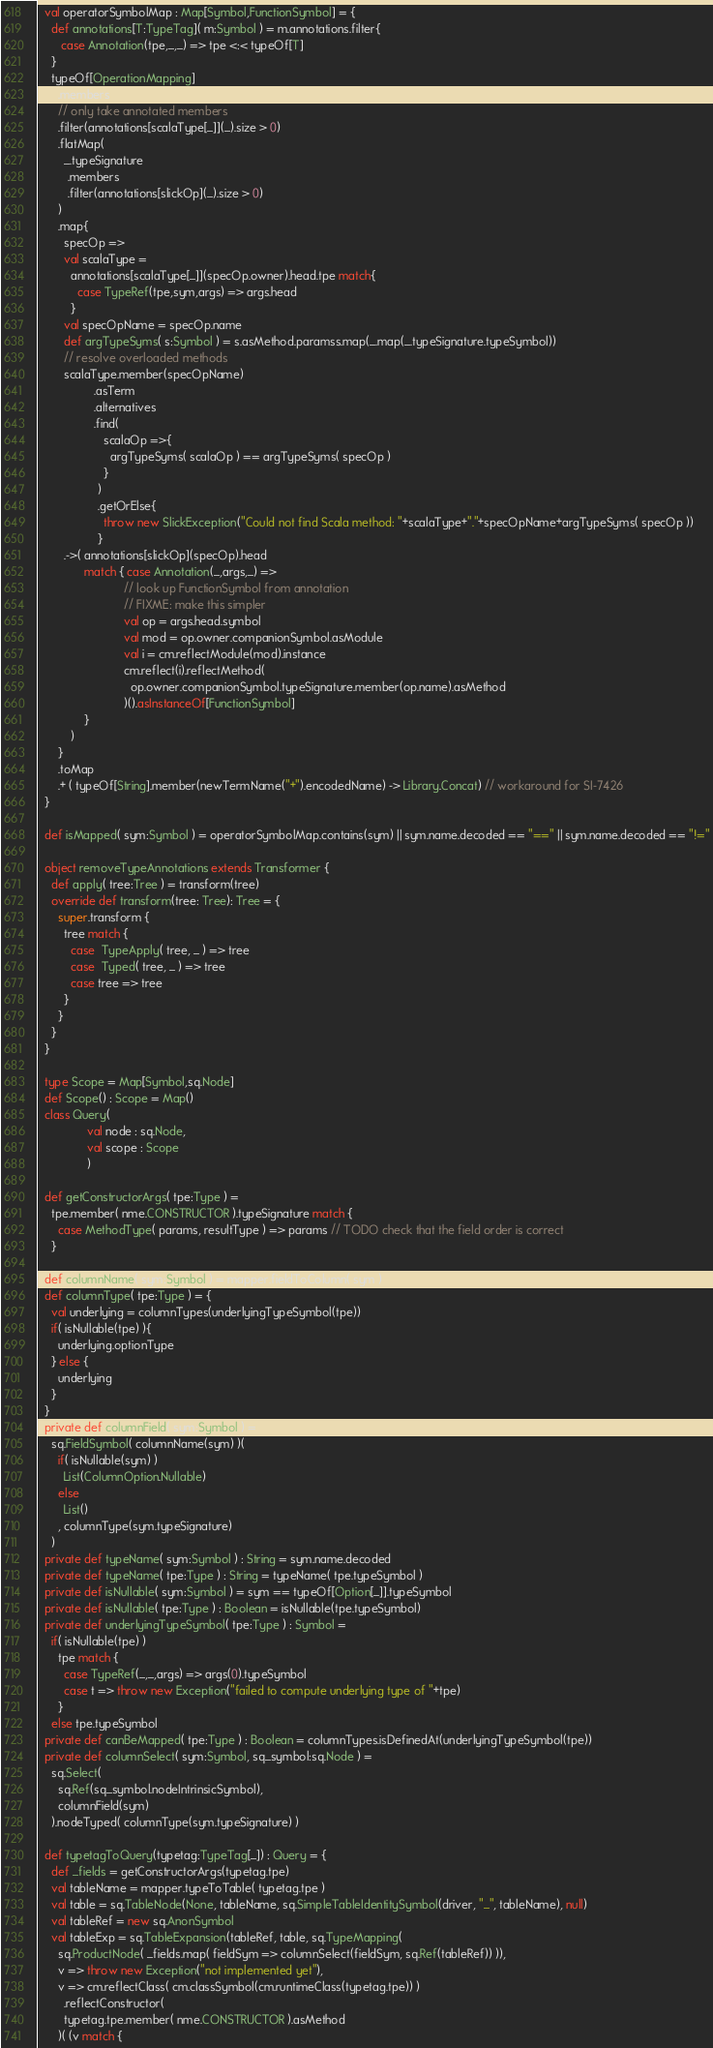Convert code to text. <code><loc_0><loc_0><loc_500><loc_500><_Scala_>  val operatorSymbolMap : Map[Symbol,FunctionSymbol] = {
    def annotations[T:TypeTag]( m:Symbol ) = m.annotations.filter{
       case Annotation(tpe,_,_) => tpe <:< typeOf[T]
    }
    typeOf[OperationMapping]
      .members
      // only take annotated members
      .filter(annotations[scalaType[_]](_).size > 0)
      .flatMap(
        _.typeSignature
         .members
         .filter(annotations[slickOp](_).size > 0)
      )
      .map{
        specOp =>
        val scalaType = 
          annotations[scalaType[_]](specOp.owner).head.tpe match{
            case TypeRef(tpe,sym,args) => args.head
          }
        val specOpName = specOp.name
        def argTypeSyms( s:Symbol ) = s.asMethod.paramss.map(_.map(_.typeSignature.typeSymbol))
        // resolve overloaded methods
        scalaType.member(specOpName) 
                 .asTerm
                 .alternatives
                 .find(
                    scalaOp =>{
                      argTypeSyms( scalaOp ) == argTypeSyms( specOp )
                    }
                  )
                  .getOrElse{
                    throw new SlickException("Could not find Scala method: "+scalaType+"."+specOpName+argTypeSyms( specOp ))
                  }
        .->( annotations[slickOp](specOp).head
              match { case Annotation(_,args,_) =>
                          // look up FunctionSymbol from annotation
                          // FIXME: make this simpler
                          val op = args.head.symbol
                          val mod = op.owner.companionSymbol.asModule
                          val i = cm.reflectModule(mod).instance
                          cm.reflect(i).reflectMethod(
                            op.owner.companionSymbol.typeSignature.member(op.name).asMethod
                          )().asInstanceOf[FunctionSymbol]
              }
          )
      }
      .toMap
      .+ ( typeOf[String].member(newTermName("+").encodedName) -> Library.Concat) // workaround for SI-7426
  }

  def isMapped( sym:Symbol ) = operatorSymbolMap.contains(sym) || sym.name.decoded == "==" || sym.name.decoded == "!="

  object removeTypeAnnotations extends Transformer {
    def apply( tree:Tree ) = transform(tree)
    override def transform(tree: Tree): Tree = {
      super.transform {
        tree match {
          case  TypeApply( tree, _ ) => tree
          case  Typed( tree, _ ) => tree
          case tree => tree
        }
      }
    }
  }

  type Scope = Map[Symbol,sq.Node]
  def Scope() : Scope = Map()
  class Query(
               val node : sq.Node,
               val scope : Scope
               )

  def getConstructorArgs( tpe:Type ) =
    tpe.member( nme.CONSTRUCTOR ).typeSignature match {
      case MethodType( params, resultType ) => params // TODO check that the field order is correct
    }

  def columnName( sym:Symbol ) = mapper.fieldToColumn( sym )
  def columnType( tpe:Type ) = {
    val underlying = columnTypes(underlyingTypeSymbol(tpe))
    if( isNullable(tpe) ){
      underlying.optionType
    } else {
      underlying
    }
  }
  private def columnField( sym:Symbol ) = 
    sq.FieldSymbol( columnName(sym) )(
      if( isNullable(sym) )
        List(ColumnOption.Nullable)
      else
        List()
      , columnType(sym.typeSignature)
    )
  private def typeName( sym:Symbol ) : String = sym.name.decoded
  private def typeName( tpe:Type ) : String = typeName( tpe.typeSymbol )
  private def isNullable( sym:Symbol ) = sym == typeOf[Option[_]].typeSymbol 
  private def isNullable( tpe:Type ) : Boolean = isNullable(tpe.typeSymbol) 
  private def underlyingTypeSymbol( tpe:Type ) : Symbol =
    if( isNullable(tpe) )
      tpe match {
        case TypeRef(_,_,args) => args(0).typeSymbol
        case t => throw new Exception("failed to compute underlying type of "+tpe)
      }
    else tpe.typeSymbol
  private def canBeMapped( tpe:Type ) : Boolean = columnTypes.isDefinedAt(underlyingTypeSymbol(tpe))
  private def columnSelect( sym:Symbol, sq_symbol:sq.Node ) =
    sq.Select(
      sq.Ref(sq_symbol.nodeIntrinsicSymbol),
      columnField(sym)
    ).nodeTyped( columnType(sym.typeSignature) )

  def typetagToQuery(typetag:TypeTag[_]) : Query = {
    def _fields = getConstructorArgs(typetag.tpe)
    val tableName = mapper.typeToTable( typetag.tpe )
    val table = sq.TableNode(None, tableName, sq.SimpleTableIdentitySymbol(driver, "_", tableName), null)
    val tableRef = new sq.AnonSymbol
    val tableExp = sq.TableExpansion(tableRef, table, sq.TypeMapping(
      sq.ProductNode( _fields.map( fieldSym => columnSelect(fieldSym, sq.Ref(tableRef)) )),
      v => throw new Exception("not implemented yet"),
      v => cm.reflectClass( cm.classSymbol(cm.runtimeClass(typetag.tpe)) )
        .reflectConstructor(
        typetag.tpe.member( nme.CONSTRUCTOR ).asMethod
      )( (v match {</code> 